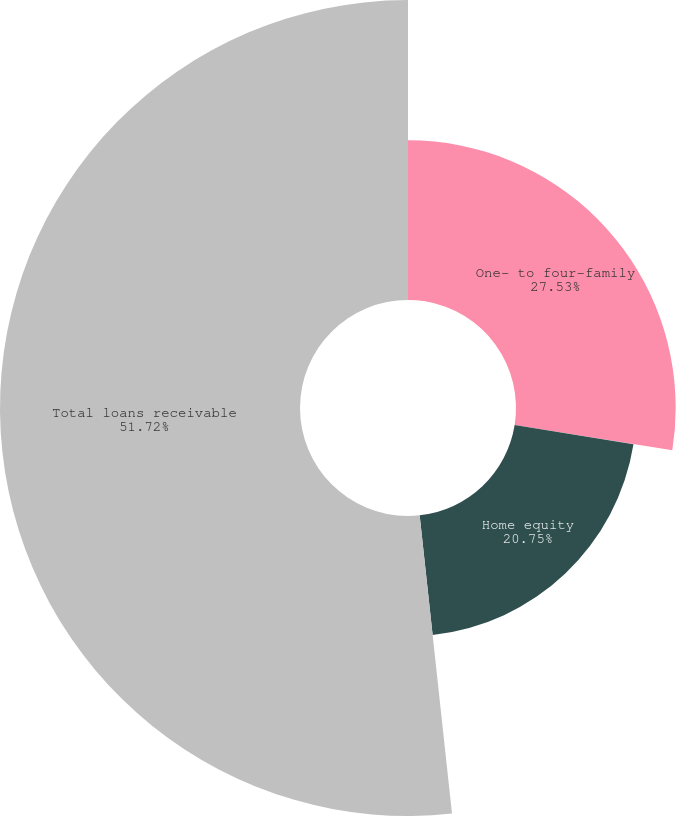Convert chart. <chart><loc_0><loc_0><loc_500><loc_500><pie_chart><fcel>One- to four-family<fcel>Home equity<fcel>Total loans receivable<nl><fcel>27.53%<fcel>20.75%<fcel>51.72%<nl></chart> 